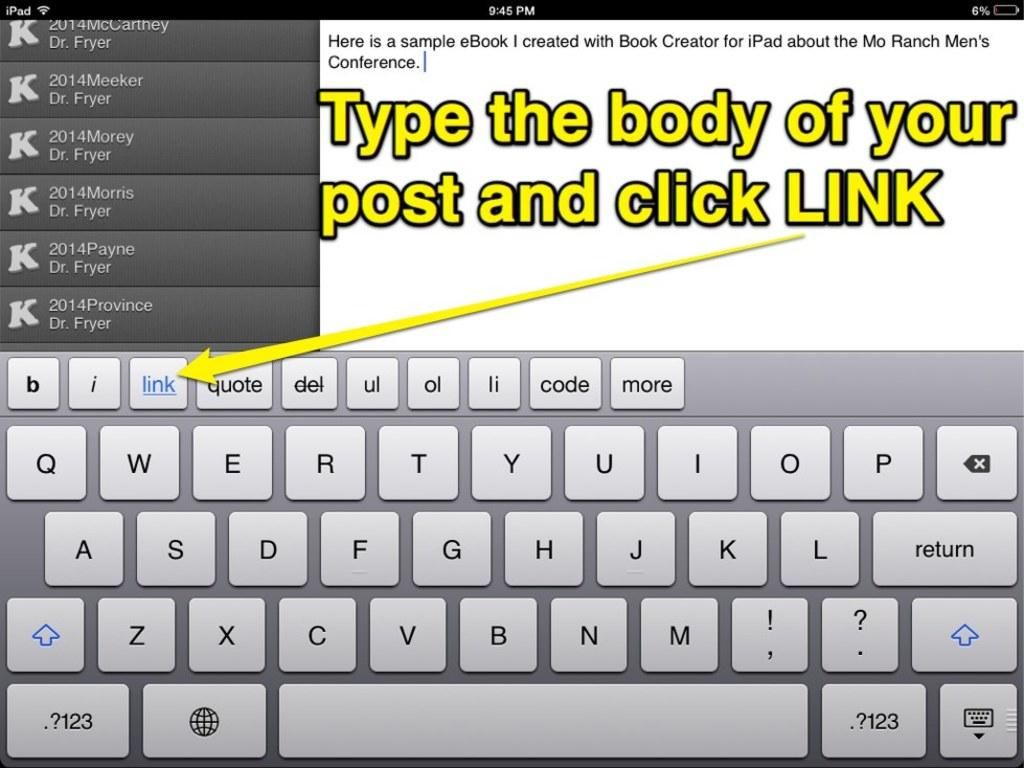<image>
Share a concise interpretation of the image provided. An image of a tablet UI with a message that reads Type the body of your Post and click LINK in yellow letters. 